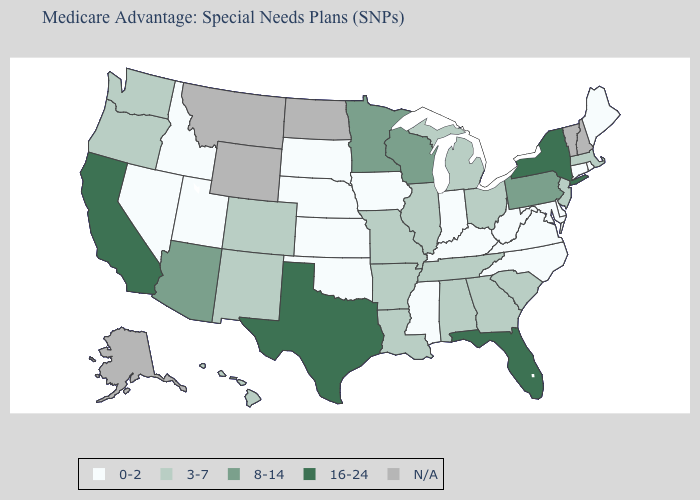How many symbols are there in the legend?
Keep it brief. 5. Name the states that have a value in the range 3-7?
Concise answer only. Alabama, Arkansas, Colorado, Georgia, Hawaii, Illinois, Louisiana, Massachusetts, Michigan, Missouri, New Jersey, New Mexico, Ohio, Oregon, South Carolina, Tennessee, Washington. Does the first symbol in the legend represent the smallest category?
Concise answer only. Yes. What is the value of Minnesota?
Short answer required. 8-14. Does Utah have the lowest value in the USA?
Keep it brief. Yes. Name the states that have a value in the range 3-7?
Quick response, please. Alabama, Arkansas, Colorado, Georgia, Hawaii, Illinois, Louisiana, Massachusetts, Michigan, Missouri, New Jersey, New Mexico, Ohio, Oregon, South Carolina, Tennessee, Washington. What is the value of Minnesota?
Write a very short answer. 8-14. Name the states that have a value in the range 3-7?
Write a very short answer. Alabama, Arkansas, Colorado, Georgia, Hawaii, Illinois, Louisiana, Massachusetts, Michigan, Missouri, New Jersey, New Mexico, Ohio, Oregon, South Carolina, Tennessee, Washington. What is the highest value in the USA?
Answer briefly. 16-24. What is the value of Wyoming?
Give a very brief answer. N/A. What is the highest value in the South ?
Quick response, please. 16-24. What is the value of Delaware?
Short answer required. 0-2. What is the lowest value in the USA?
Short answer required. 0-2. What is the value of Washington?
Give a very brief answer. 3-7. Does Minnesota have the lowest value in the MidWest?
Short answer required. No. 